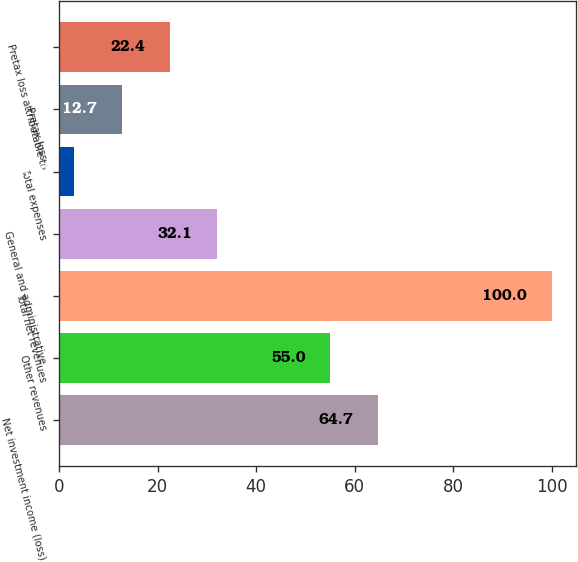Convert chart. <chart><loc_0><loc_0><loc_500><loc_500><bar_chart><fcel>Net investment income (loss)<fcel>Other revenues<fcel>Total net revenues<fcel>General and administrative<fcel>Total expenses<fcel>Pretax loss<fcel>Pretax loss attributable to<nl><fcel>64.7<fcel>55<fcel>100<fcel>32.1<fcel>3<fcel>12.7<fcel>22.4<nl></chart> 